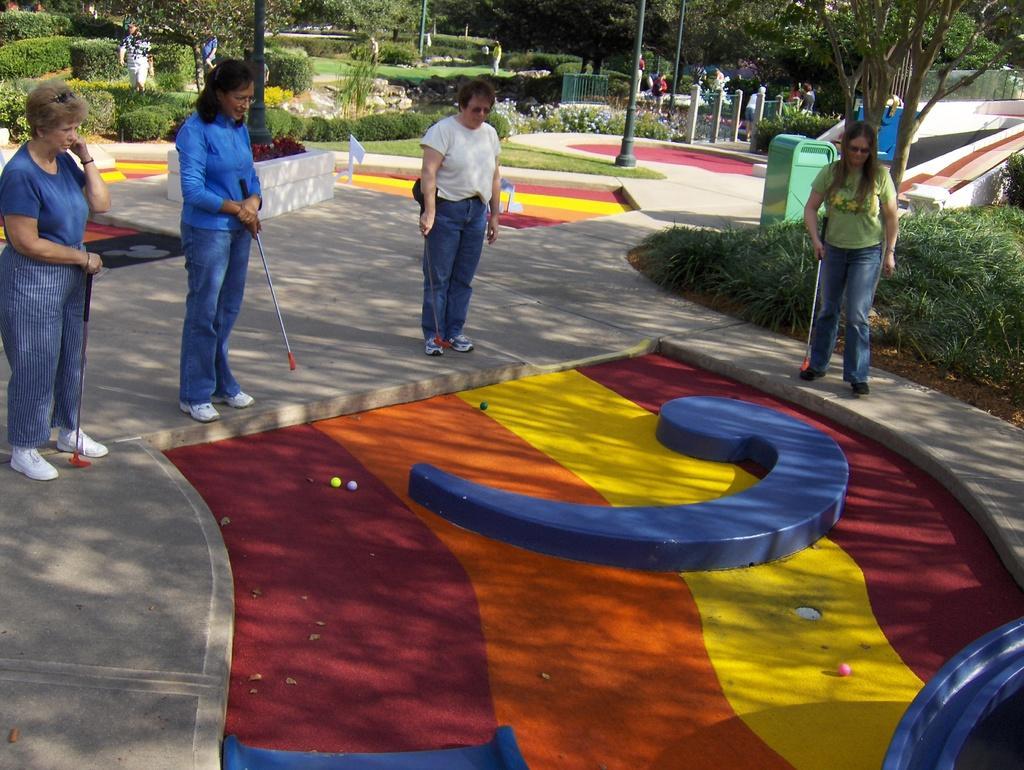Please provide a concise description of this image. In this picture we can see a few people are standing on the floor and they are playing games, beside we can see so many trees and grass. 